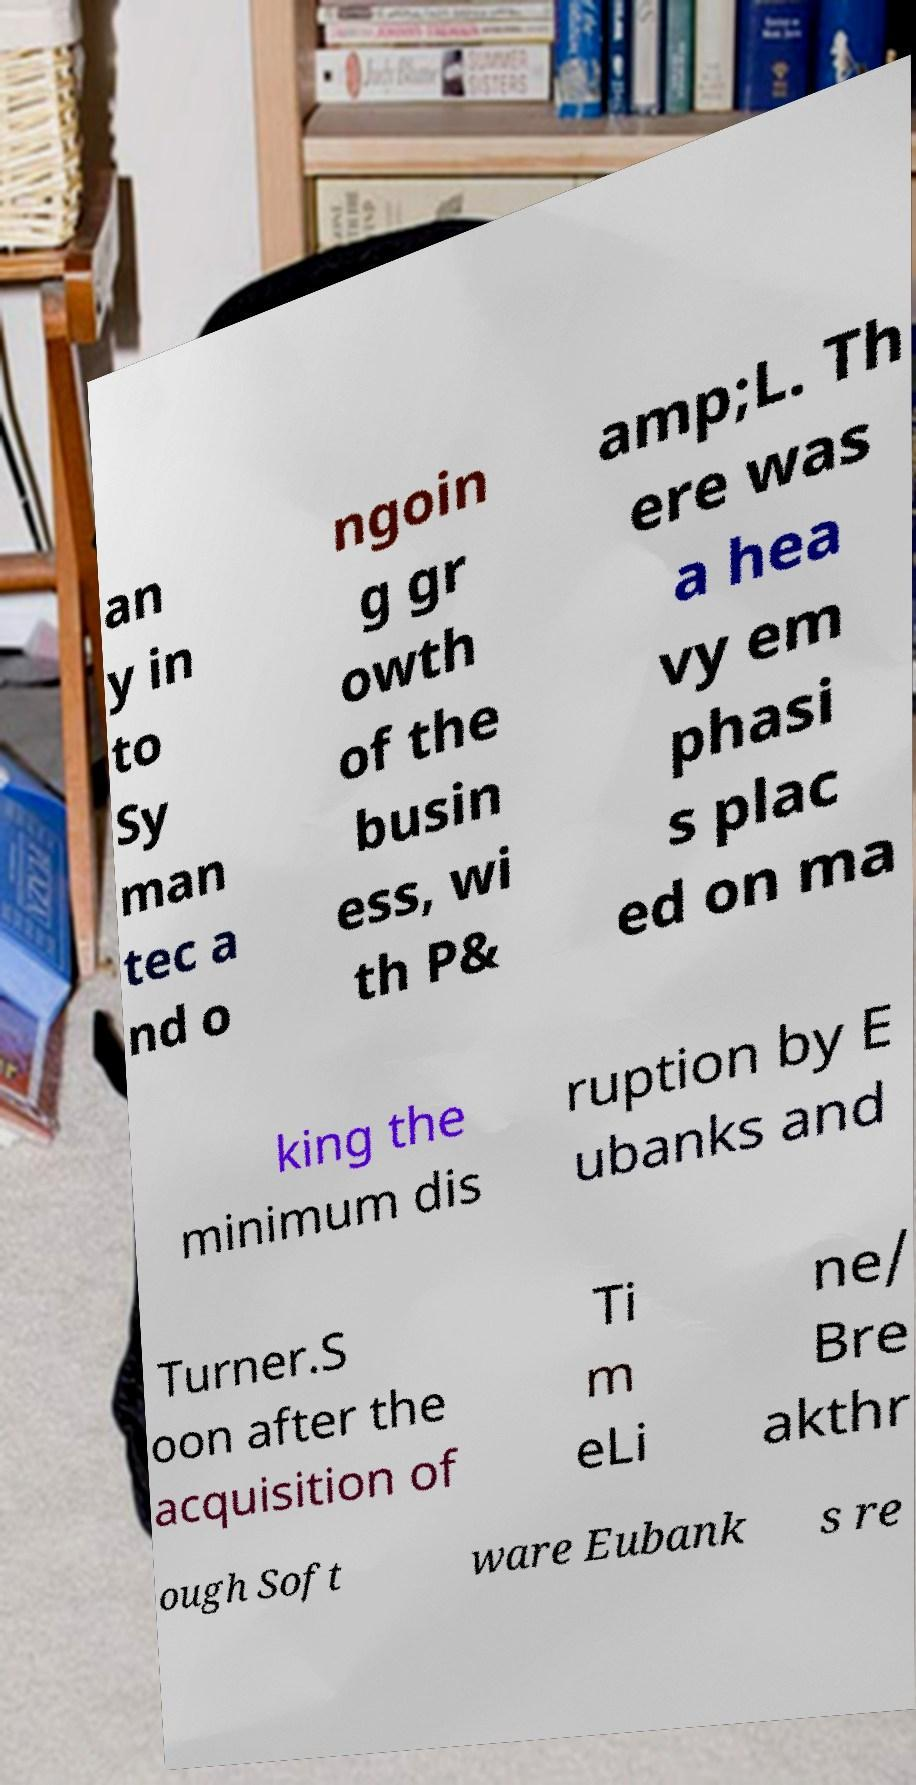What messages or text are displayed in this image? I need them in a readable, typed format. an y in to Sy man tec a nd o ngoin g gr owth of the busin ess, wi th P& amp;L. Th ere was a hea vy em phasi s plac ed on ma king the minimum dis ruption by E ubanks and Turner.S oon after the acquisition of Ti m eLi ne/ Bre akthr ough Soft ware Eubank s re 